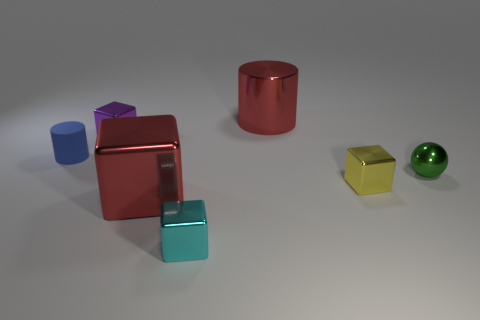The small object that is both left of the big block and right of the blue matte thing has what shape?
Give a very brief answer. Cube. How many other things are there of the same shape as the tiny yellow thing?
Keep it short and to the point. 3. There is a metal ball that is the same size as the cyan object; what color is it?
Provide a succinct answer. Green. How many things are purple shiny blocks or tiny gray metallic cubes?
Keep it short and to the point. 1. There is a green object; are there any cyan shiny blocks behind it?
Make the answer very short. No. Is there a tiny green ball made of the same material as the small yellow cube?
Your answer should be very brief. Yes. The metallic cylinder that is the same color as the large metal cube is what size?
Make the answer very short. Large. What number of cubes are either tiny metallic things or small things?
Keep it short and to the point. 3. Are there more tiny cyan objects behind the tiny purple metal block than small cyan blocks that are in front of the cyan metal thing?
Your answer should be very brief. No. What number of cylinders have the same color as the large block?
Make the answer very short. 1. 